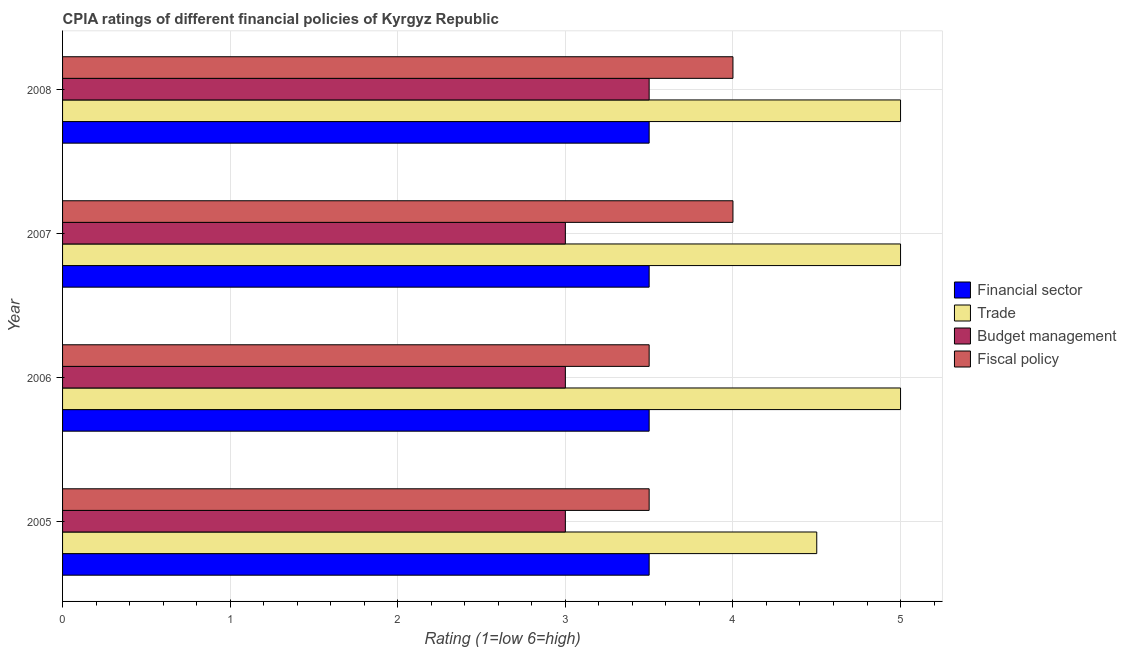How many different coloured bars are there?
Your answer should be compact. 4. How many groups of bars are there?
Ensure brevity in your answer.  4. Are the number of bars on each tick of the Y-axis equal?
Give a very brief answer. Yes. What is the label of the 1st group of bars from the top?
Provide a succinct answer. 2008. What is the cpia rating of trade in 2006?
Give a very brief answer. 5. Across all years, what is the maximum cpia rating of financial sector?
Offer a very short reply. 3.5. Across all years, what is the minimum cpia rating of fiscal policy?
Make the answer very short. 3.5. In which year was the cpia rating of trade maximum?
Offer a terse response. 2006. What is the difference between the cpia rating of fiscal policy in 2007 and that in 2008?
Your response must be concise. 0. What is the average cpia rating of fiscal policy per year?
Offer a terse response. 3.75. In how many years, is the cpia rating of budget management greater than 1.8 ?
Provide a short and direct response. 4. What is the ratio of the cpia rating of budget management in 2007 to that in 2008?
Give a very brief answer. 0.86. Is the difference between the cpia rating of budget management in 2005 and 2007 greater than the difference between the cpia rating of fiscal policy in 2005 and 2007?
Make the answer very short. Yes. Is it the case that in every year, the sum of the cpia rating of trade and cpia rating of budget management is greater than the sum of cpia rating of financial sector and cpia rating of fiscal policy?
Offer a very short reply. No. What does the 3rd bar from the top in 2007 represents?
Offer a terse response. Trade. What does the 3rd bar from the bottom in 2007 represents?
Your answer should be compact. Budget management. Is it the case that in every year, the sum of the cpia rating of financial sector and cpia rating of trade is greater than the cpia rating of budget management?
Give a very brief answer. Yes. How many bars are there?
Give a very brief answer. 16. Are all the bars in the graph horizontal?
Your answer should be very brief. Yes. How many legend labels are there?
Give a very brief answer. 4. What is the title of the graph?
Your answer should be compact. CPIA ratings of different financial policies of Kyrgyz Republic. Does "United States" appear as one of the legend labels in the graph?
Your answer should be compact. No. What is the Rating (1=low 6=high) of Trade in 2005?
Make the answer very short. 4.5. What is the Rating (1=low 6=high) in Budget management in 2005?
Your answer should be compact. 3. What is the Rating (1=low 6=high) in Financial sector in 2006?
Keep it short and to the point. 3.5. What is the Rating (1=low 6=high) in Fiscal policy in 2006?
Provide a short and direct response. 3.5. What is the Rating (1=low 6=high) in Financial sector in 2007?
Your response must be concise. 3.5. What is the Rating (1=low 6=high) in Budget management in 2007?
Make the answer very short. 3. What is the Rating (1=low 6=high) in Financial sector in 2008?
Your answer should be compact. 3.5. What is the Rating (1=low 6=high) of Fiscal policy in 2008?
Your answer should be very brief. 4. Across all years, what is the maximum Rating (1=low 6=high) in Budget management?
Provide a succinct answer. 3.5. Across all years, what is the minimum Rating (1=low 6=high) of Financial sector?
Give a very brief answer. 3.5. What is the total Rating (1=low 6=high) in Financial sector in the graph?
Ensure brevity in your answer.  14. What is the total Rating (1=low 6=high) in Trade in the graph?
Give a very brief answer. 19.5. What is the total Rating (1=low 6=high) of Fiscal policy in the graph?
Your response must be concise. 15. What is the difference between the Rating (1=low 6=high) in Trade in 2005 and that in 2006?
Make the answer very short. -0.5. What is the difference between the Rating (1=low 6=high) in Fiscal policy in 2005 and that in 2006?
Your answer should be compact. 0. What is the difference between the Rating (1=low 6=high) in Financial sector in 2005 and that in 2007?
Your response must be concise. 0. What is the difference between the Rating (1=low 6=high) of Financial sector in 2005 and that in 2008?
Your answer should be compact. 0. What is the difference between the Rating (1=low 6=high) of Budget management in 2005 and that in 2008?
Offer a very short reply. -0.5. What is the difference between the Rating (1=low 6=high) of Fiscal policy in 2005 and that in 2008?
Keep it short and to the point. -0.5. What is the difference between the Rating (1=low 6=high) of Budget management in 2006 and that in 2007?
Give a very brief answer. 0. What is the difference between the Rating (1=low 6=high) in Financial sector in 2006 and that in 2008?
Provide a short and direct response. 0. What is the difference between the Rating (1=low 6=high) of Trade in 2006 and that in 2008?
Keep it short and to the point. 0. What is the difference between the Rating (1=low 6=high) in Budget management in 2006 and that in 2008?
Offer a very short reply. -0.5. What is the difference between the Rating (1=low 6=high) in Trade in 2007 and that in 2008?
Offer a terse response. 0. What is the difference between the Rating (1=low 6=high) of Budget management in 2007 and that in 2008?
Keep it short and to the point. -0.5. What is the difference between the Rating (1=low 6=high) of Financial sector in 2005 and the Rating (1=low 6=high) of Budget management in 2006?
Keep it short and to the point. 0.5. What is the difference between the Rating (1=low 6=high) of Financial sector in 2005 and the Rating (1=low 6=high) of Fiscal policy in 2006?
Provide a short and direct response. 0. What is the difference between the Rating (1=low 6=high) of Trade in 2005 and the Rating (1=low 6=high) of Budget management in 2006?
Provide a succinct answer. 1.5. What is the difference between the Rating (1=low 6=high) in Trade in 2005 and the Rating (1=low 6=high) in Fiscal policy in 2006?
Offer a terse response. 1. What is the difference between the Rating (1=low 6=high) of Budget management in 2005 and the Rating (1=low 6=high) of Fiscal policy in 2006?
Provide a short and direct response. -0.5. What is the difference between the Rating (1=low 6=high) of Financial sector in 2005 and the Rating (1=low 6=high) of Trade in 2007?
Your answer should be compact. -1.5. What is the difference between the Rating (1=low 6=high) of Financial sector in 2005 and the Rating (1=low 6=high) of Trade in 2008?
Your answer should be very brief. -1.5. What is the difference between the Rating (1=low 6=high) in Financial sector in 2005 and the Rating (1=low 6=high) in Fiscal policy in 2008?
Your answer should be compact. -0.5. What is the difference between the Rating (1=low 6=high) of Trade in 2005 and the Rating (1=low 6=high) of Budget management in 2008?
Keep it short and to the point. 1. What is the difference between the Rating (1=low 6=high) of Trade in 2005 and the Rating (1=low 6=high) of Fiscal policy in 2008?
Keep it short and to the point. 0.5. What is the difference between the Rating (1=low 6=high) in Budget management in 2005 and the Rating (1=low 6=high) in Fiscal policy in 2008?
Provide a succinct answer. -1. What is the difference between the Rating (1=low 6=high) of Financial sector in 2006 and the Rating (1=low 6=high) of Trade in 2007?
Make the answer very short. -1.5. What is the difference between the Rating (1=low 6=high) of Trade in 2006 and the Rating (1=low 6=high) of Budget management in 2007?
Provide a succinct answer. 2. What is the difference between the Rating (1=low 6=high) of Financial sector in 2006 and the Rating (1=low 6=high) of Fiscal policy in 2008?
Offer a very short reply. -0.5. What is the difference between the Rating (1=low 6=high) of Financial sector in 2007 and the Rating (1=low 6=high) of Trade in 2008?
Offer a very short reply. -1.5. What is the difference between the Rating (1=low 6=high) of Trade in 2007 and the Rating (1=low 6=high) of Budget management in 2008?
Offer a very short reply. 1.5. What is the difference between the Rating (1=low 6=high) in Budget management in 2007 and the Rating (1=low 6=high) in Fiscal policy in 2008?
Your answer should be compact. -1. What is the average Rating (1=low 6=high) in Trade per year?
Make the answer very short. 4.88. What is the average Rating (1=low 6=high) in Budget management per year?
Offer a terse response. 3.12. What is the average Rating (1=low 6=high) of Fiscal policy per year?
Offer a very short reply. 3.75. In the year 2005, what is the difference between the Rating (1=low 6=high) in Financial sector and Rating (1=low 6=high) in Trade?
Make the answer very short. -1. In the year 2005, what is the difference between the Rating (1=low 6=high) of Financial sector and Rating (1=low 6=high) of Budget management?
Make the answer very short. 0.5. In the year 2005, what is the difference between the Rating (1=low 6=high) of Trade and Rating (1=low 6=high) of Budget management?
Provide a succinct answer. 1.5. In the year 2005, what is the difference between the Rating (1=low 6=high) of Budget management and Rating (1=low 6=high) of Fiscal policy?
Make the answer very short. -0.5. In the year 2006, what is the difference between the Rating (1=low 6=high) in Financial sector and Rating (1=low 6=high) in Trade?
Provide a succinct answer. -1.5. In the year 2006, what is the difference between the Rating (1=low 6=high) of Financial sector and Rating (1=low 6=high) of Fiscal policy?
Provide a short and direct response. 0. In the year 2006, what is the difference between the Rating (1=low 6=high) in Trade and Rating (1=low 6=high) in Fiscal policy?
Provide a succinct answer. 1.5. In the year 2006, what is the difference between the Rating (1=low 6=high) in Budget management and Rating (1=low 6=high) in Fiscal policy?
Offer a terse response. -0.5. In the year 2007, what is the difference between the Rating (1=low 6=high) in Financial sector and Rating (1=low 6=high) in Trade?
Your answer should be very brief. -1.5. In the year 2007, what is the difference between the Rating (1=low 6=high) of Financial sector and Rating (1=low 6=high) of Fiscal policy?
Your response must be concise. -0.5. In the year 2007, what is the difference between the Rating (1=low 6=high) of Trade and Rating (1=low 6=high) of Budget management?
Offer a terse response. 2. In the year 2007, what is the difference between the Rating (1=low 6=high) of Budget management and Rating (1=low 6=high) of Fiscal policy?
Your response must be concise. -1. In the year 2008, what is the difference between the Rating (1=low 6=high) in Financial sector and Rating (1=low 6=high) in Trade?
Your response must be concise. -1.5. In the year 2008, what is the difference between the Rating (1=low 6=high) in Financial sector and Rating (1=low 6=high) in Fiscal policy?
Ensure brevity in your answer.  -0.5. In the year 2008, what is the difference between the Rating (1=low 6=high) in Trade and Rating (1=low 6=high) in Budget management?
Offer a very short reply. 1.5. In the year 2008, what is the difference between the Rating (1=low 6=high) in Trade and Rating (1=low 6=high) in Fiscal policy?
Offer a terse response. 1. In the year 2008, what is the difference between the Rating (1=low 6=high) in Budget management and Rating (1=low 6=high) in Fiscal policy?
Offer a very short reply. -0.5. What is the ratio of the Rating (1=low 6=high) of Financial sector in 2005 to that in 2006?
Keep it short and to the point. 1. What is the ratio of the Rating (1=low 6=high) in Trade in 2005 to that in 2007?
Keep it short and to the point. 0.9. What is the ratio of the Rating (1=low 6=high) of Budget management in 2005 to that in 2007?
Give a very brief answer. 1. What is the ratio of the Rating (1=low 6=high) in Financial sector in 2005 to that in 2008?
Your answer should be very brief. 1. What is the ratio of the Rating (1=low 6=high) of Trade in 2005 to that in 2008?
Your answer should be compact. 0.9. What is the ratio of the Rating (1=low 6=high) of Fiscal policy in 2005 to that in 2008?
Keep it short and to the point. 0.88. What is the ratio of the Rating (1=low 6=high) of Financial sector in 2006 to that in 2008?
Give a very brief answer. 1. What is the ratio of the Rating (1=low 6=high) in Budget management in 2006 to that in 2008?
Ensure brevity in your answer.  0.86. What is the ratio of the Rating (1=low 6=high) of Financial sector in 2007 to that in 2008?
Your answer should be compact. 1. What is the ratio of the Rating (1=low 6=high) of Trade in 2007 to that in 2008?
Provide a succinct answer. 1. What is the ratio of the Rating (1=low 6=high) of Fiscal policy in 2007 to that in 2008?
Offer a terse response. 1. What is the difference between the highest and the second highest Rating (1=low 6=high) of Financial sector?
Ensure brevity in your answer.  0. What is the difference between the highest and the lowest Rating (1=low 6=high) of Trade?
Make the answer very short. 0.5. 